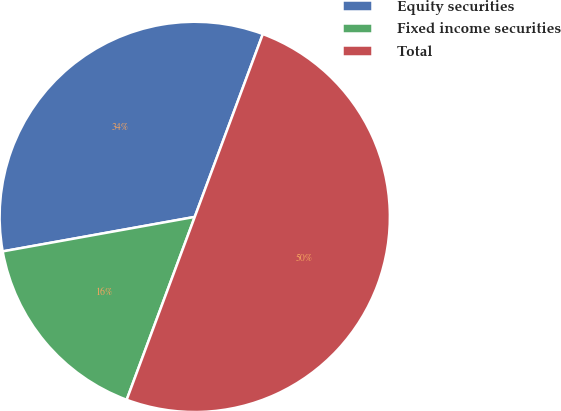<chart> <loc_0><loc_0><loc_500><loc_500><pie_chart><fcel>Equity securities<fcel>Fixed income securities<fcel>Total<nl><fcel>33.5%<fcel>16.5%<fcel>50.0%<nl></chart> 